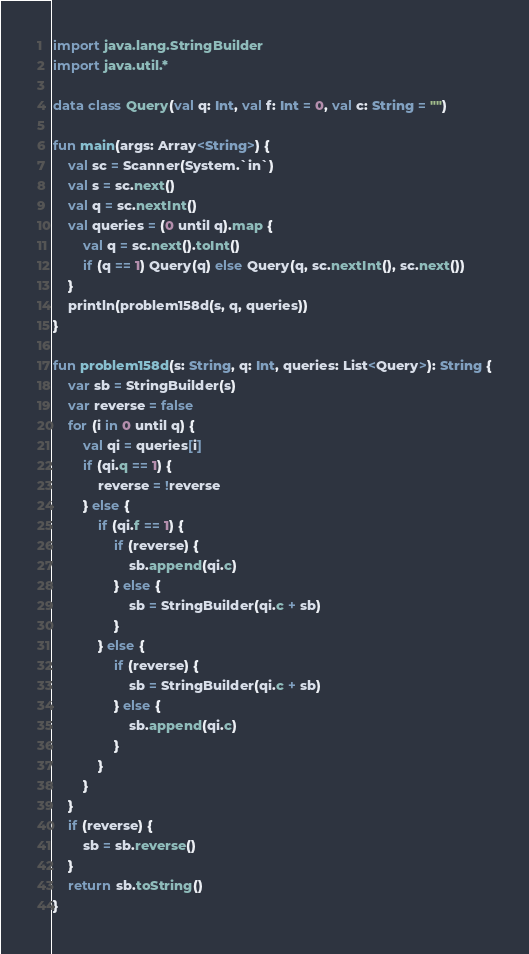Convert code to text. <code><loc_0><loc_0><loc_500><loc_500><_Kotlin_>import java.lang.StringBuilder
import java.util.*

data class Query(val q: Int, val f: Int = 0, val c: String = "")

fun main(args: Array<String>) {
    val sc = Scanner(System.`in`)
    val s = sc.next()
    val q = sc.nextInt()
    val queries = (0 until q).map {
        val q = sc.next().toInt()
        if (q == 1) Query(q) else Query(q, sc.nextInt(), sc.next())
    }
    println(problem158d(s, q, queries))
}

fun problem158d(s: String, q: Int, queries: List<Query>): String {
    var sb = StringBuilder(s)
    var reverse = false
    for (i in 0 until q) {
        val qi = queries[i]
        if (qi.q == 1) {
            reverse = !reverse
        } else {
            if (qi.f == 1) {
                if (reverse) {
                    sb.append(qi.c)
                } else {
                    sb = StringBuilder(qi.c + sb)
                }
            } else {
                if (reverse) {
                    sb = StringBuilder(qi.c + sb)
                } else {
                    sb.append(qi.c)
                }
            }
        }
    }
    if (reverse) {
        sb = sb.reverse()
    }
    return sb.toString()
}</code> 